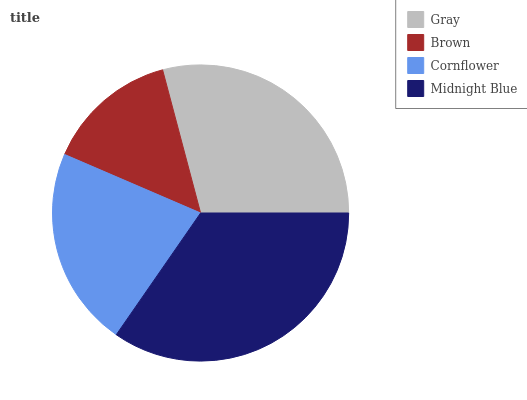Is Brown the minimum?
Answer yes or no. Yes. Is Midnight Blue the maximum?
Answer yes or no. Yes. Is Cornflower the minimum?
Answer yes or no. No. Is Cornflower the maximum?
Answer yes or no. No. Is Cornflower greater than Brown?
Answer yes or no. Yes. Is Brown less than Cornflower?
Answer yes or no. Yes. Is Brown greater than Cornflower?
Answer yes or no. No. Is Cornflower less than Brown?
Answer yes or no. No. Is Gray the high median?
Answer yes or no. Yes. Is Cornflower the low median?
Answer yes or no. Yes. Is Cornflower the high median?
Answer yes or no. No. Is Gray the low median?
Answer yes or no. No. 